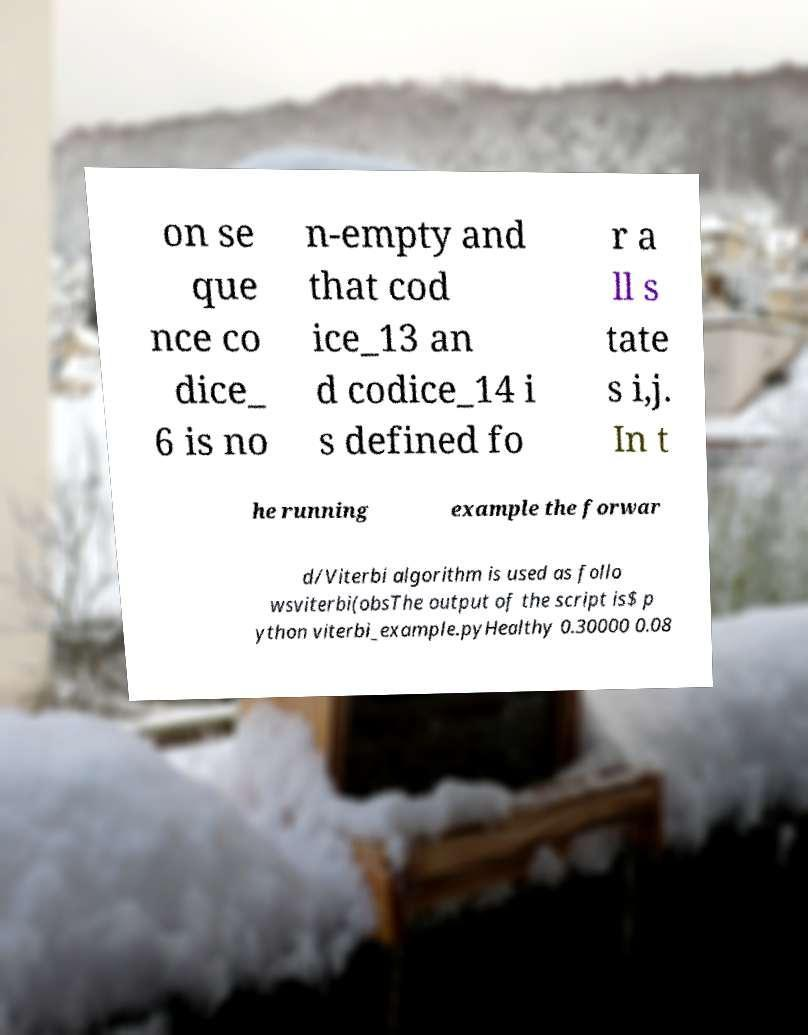Please identify and transcribe the text found in this image. on se que nce co dice_ 6 is no n-empty and that cod ice_13 an d codice_14 i s defined fo r a ll s tate s i,j. In t he running example the forwar d/Viterbi algorithm is used as follo wsviterbi(obsThe output of the script is$ p ython viterbi_example.pyHealthy 0.30000 0.08 